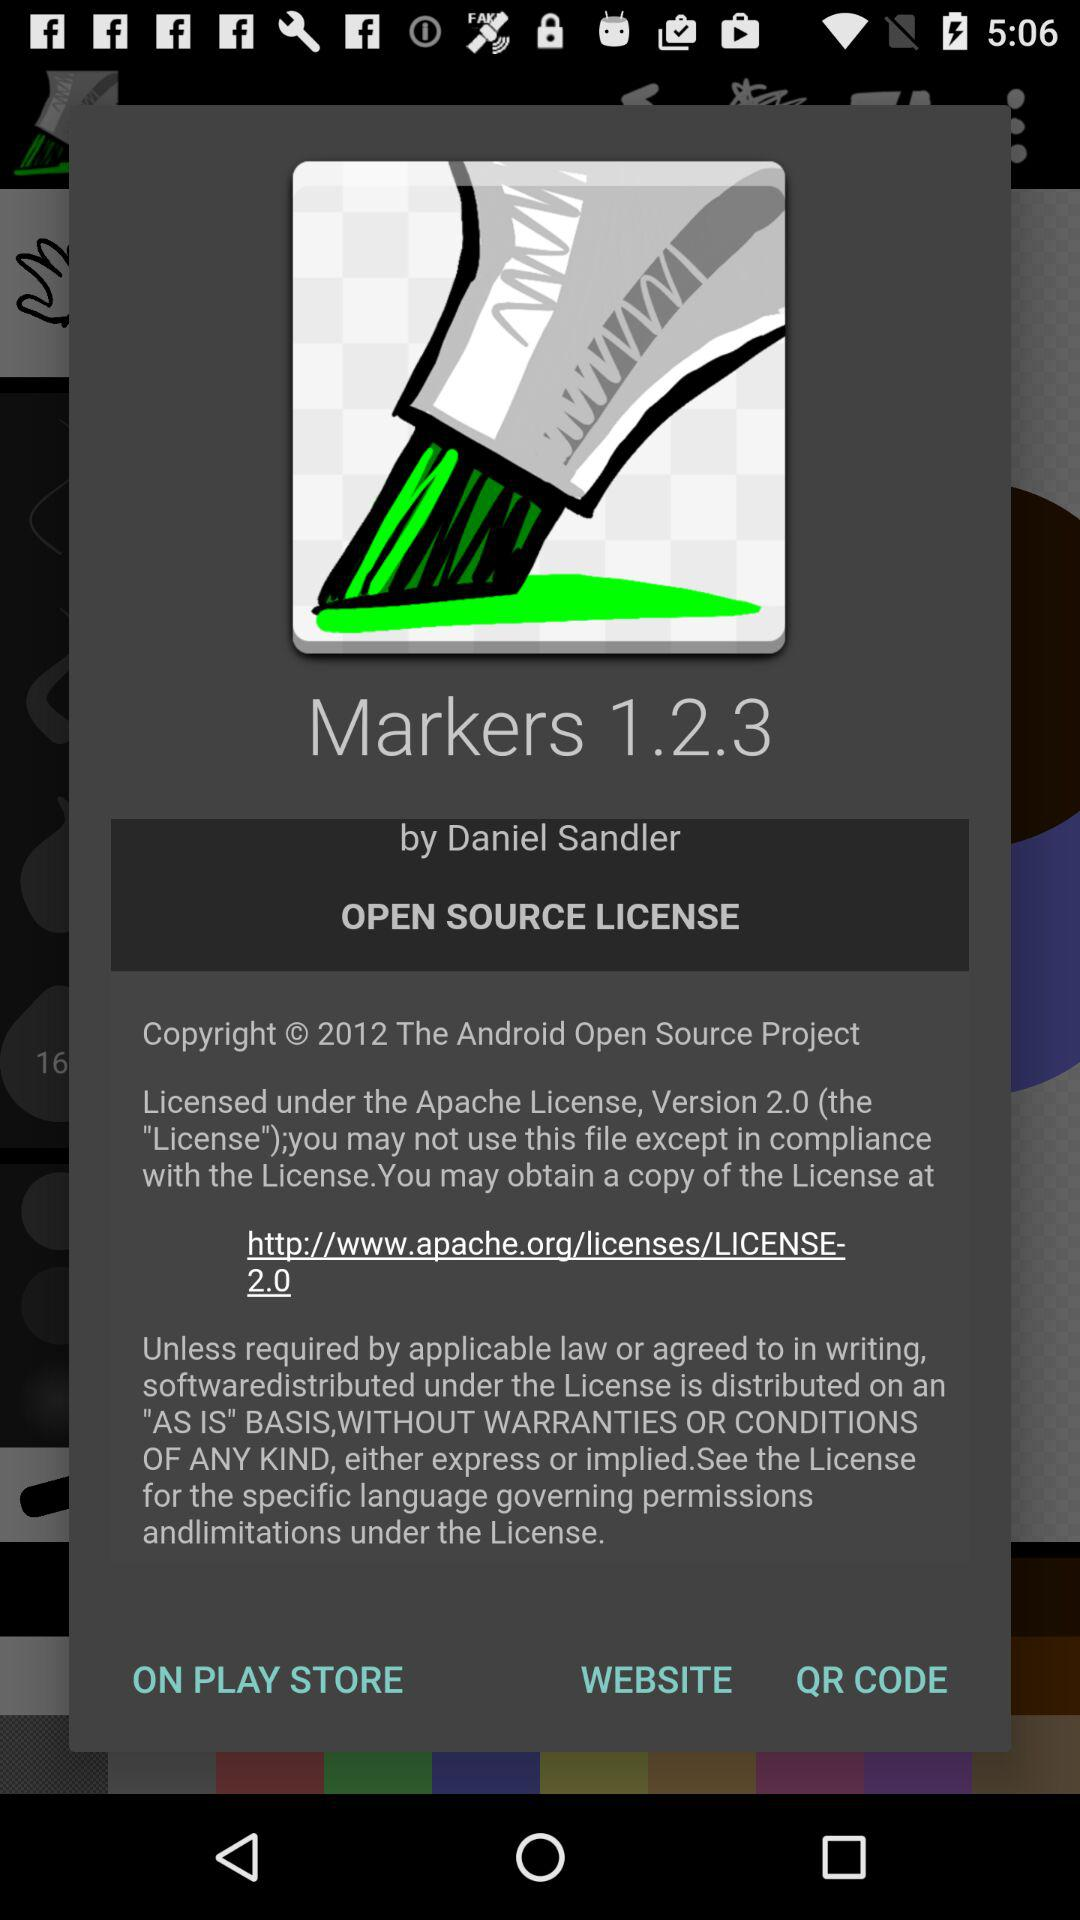Who is the developer? The developer is Daniel Sandler. 